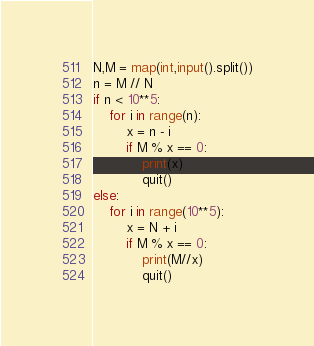Convert code to text. <code><loc_0><loc_0><loc_500><loc_500><_Python_>N,M = map(int,input().split())
n = M // N
if n < 10**5:
    for i in range(n):
        x = n - i
        if M % x == 0:
            print(x)
            quit()
else:
    for i in range(10**5):
        x = N + i
        if M % x == 0:
            print(M//x)
            quit()</code> 